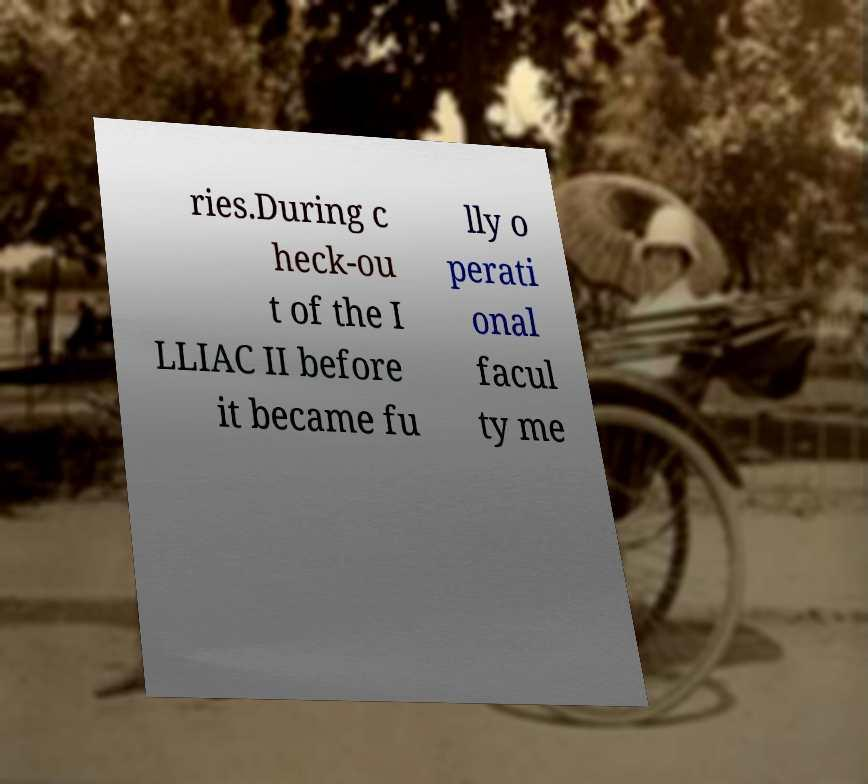Please identify and transcribe the text found in this image. ries.During c heck-ou t of the I LLIAC II before it became fu lly o perati onal facul ty me 